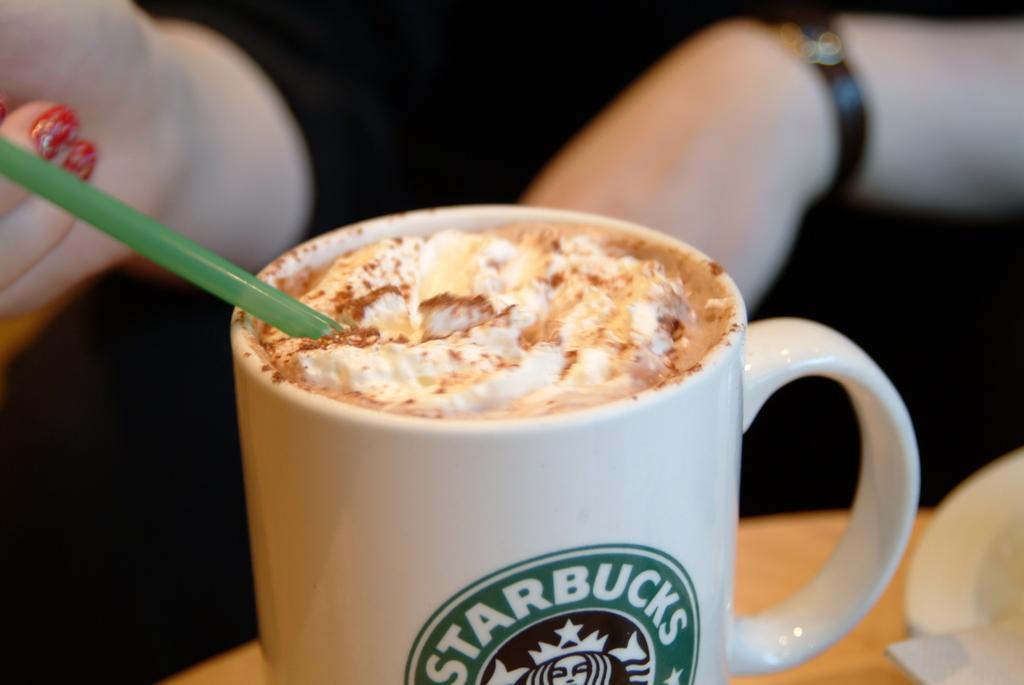Could you give a brief overview of what you see in this image? In this image there is a table, on that table there is mug in that mug there is liquid , a woman sitting near the table kept a straw in the mug. 